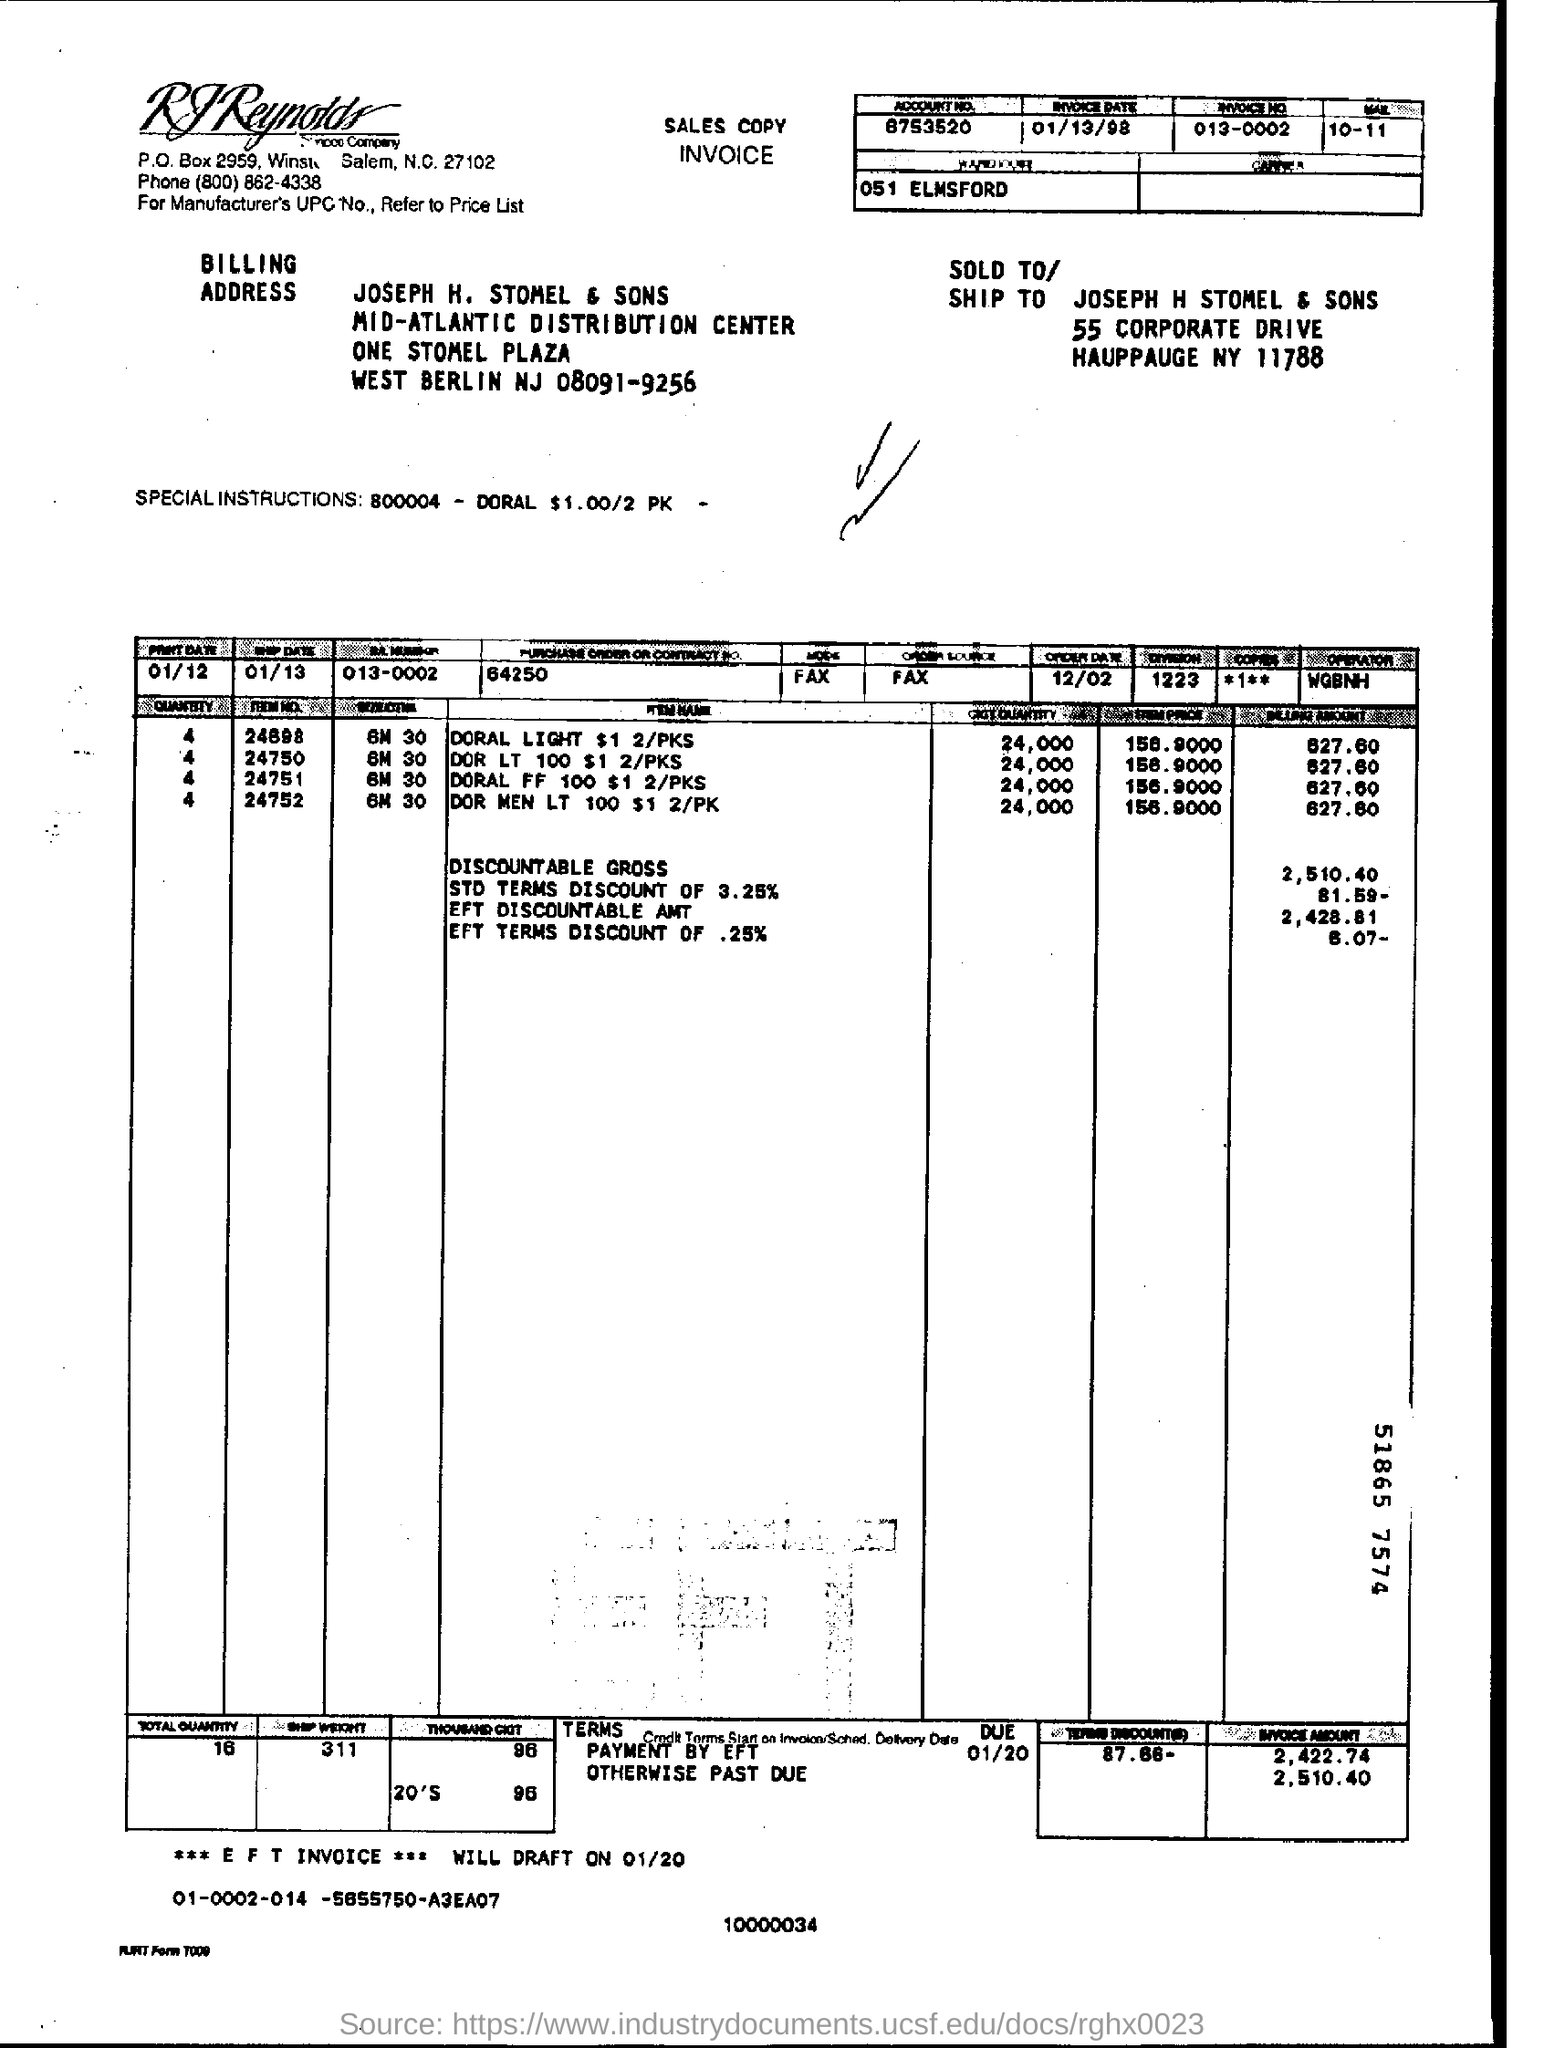Indicate a few pertinent items in this graphic. When will the draft for the EFT INVOICE for 01/20 be created? The order date is December 02. The invoice date is January 13, 1998. 